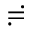<formula> <loc_0><loc_0><loc_500><loc_500>\risingdotseq</formula> 